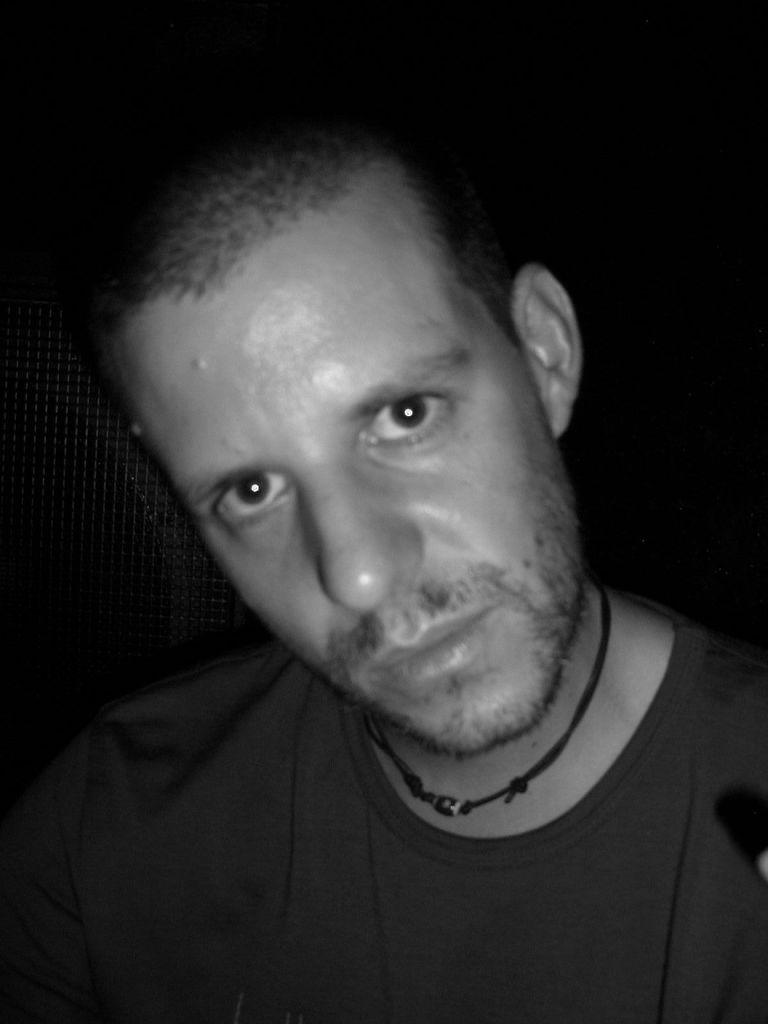What is the color scheme of the image? The image is a black and white picture. What is the main subject of the image? The picture depicts a person. What type of copper material is present in the image? There is no copper material present in the image; it is a black and white picture of a person. What committee is the person in the image a part of? There is no information about a committee in the image; it only depicts a person. 